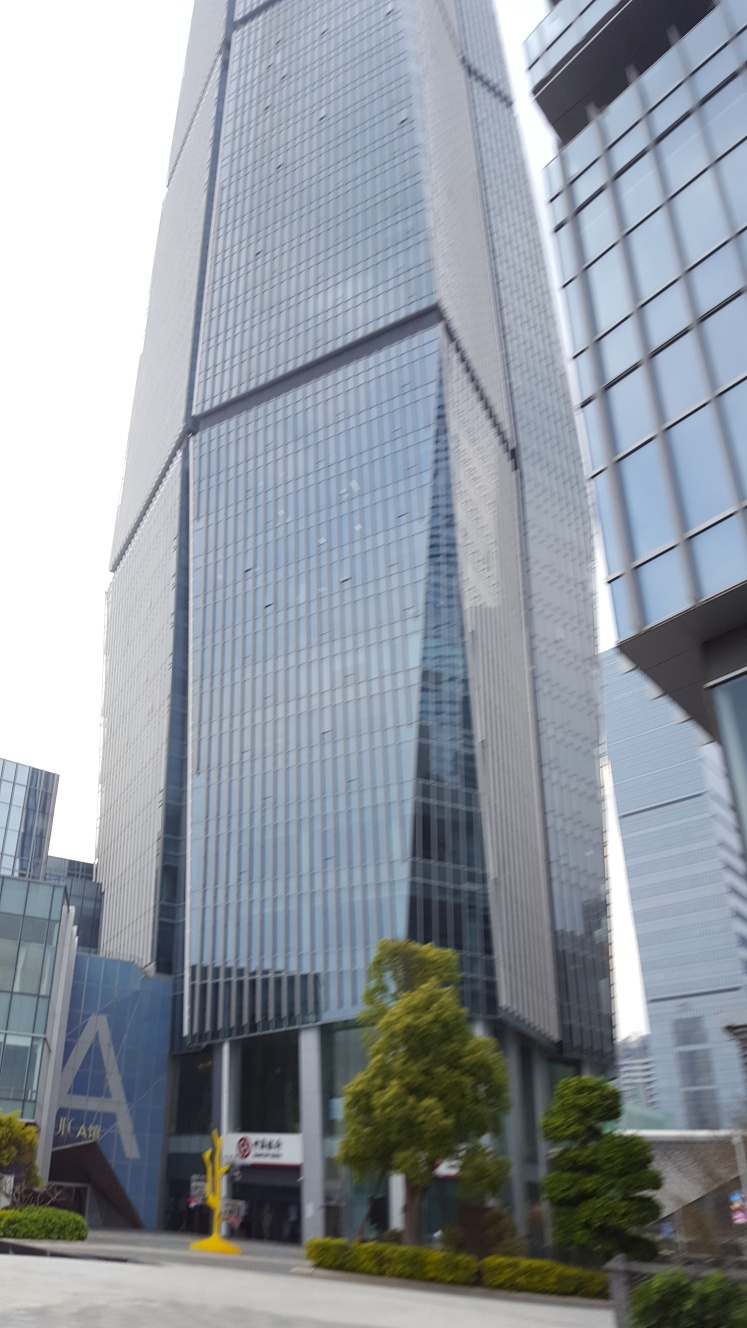Is the composition of the image good? Based on the image provided, the composition appears to be slightly tilted, which disrupts the balance of the photograph. However, the framing does capture the imposing stature of the buildings, the clear sky, and the surrounding elements like the vegetation and street features, contributing to the urban atmosphere. For a more aesthetically pleasing composition, a straighter perspective to align with the vertical lines of the architecture would be beneficial. 